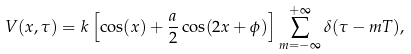<formula> <loc_0><loc_0><loc_500><loc_500>V ( x , \tau ) = k \left [ \cos ( x ) + \frac { a } { 2 } \cos ( 2 x + \phi ) \right ] \sum _ { m = - \infty } ^ { + \infty } \delta ( \tau - m T ) ,</formula> 